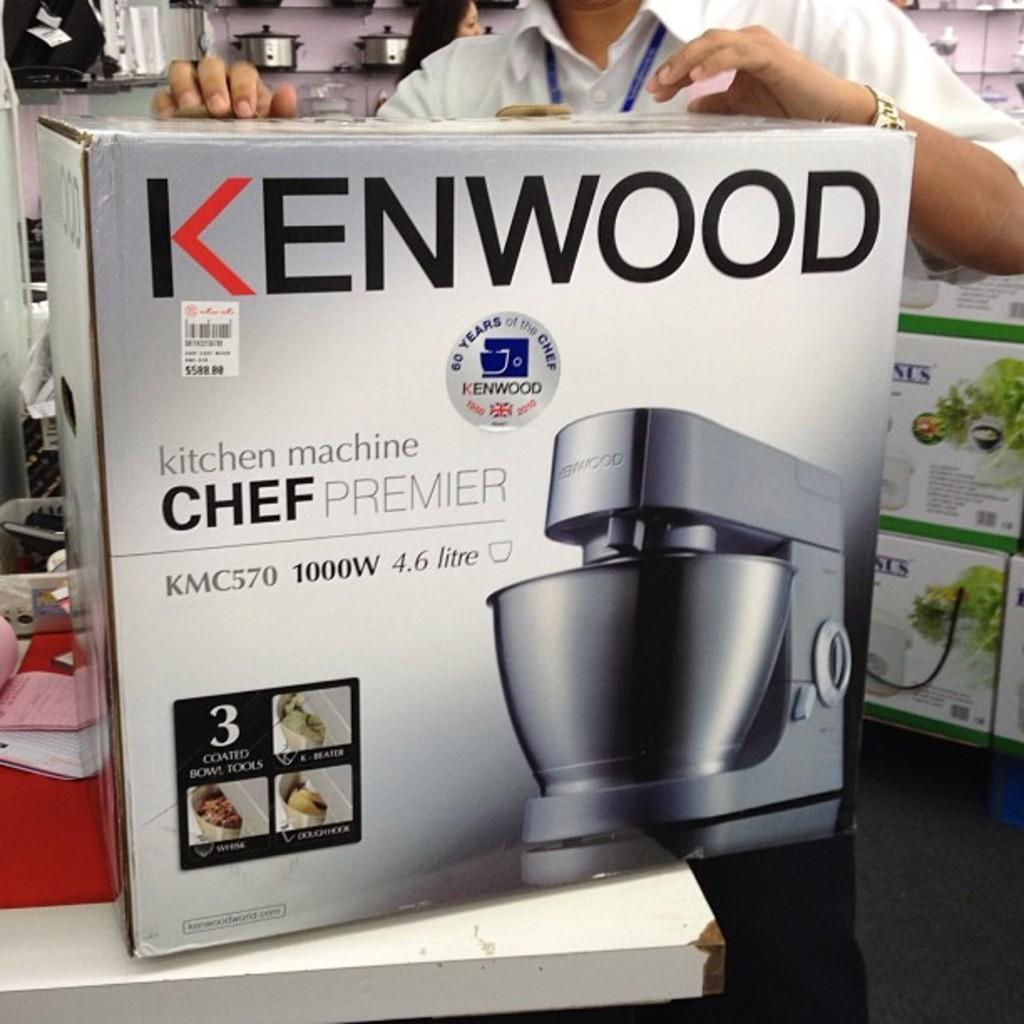<image>
Present a compact description of the photo's key features. A Kenwood brand kitchen machine is still in in its original box 